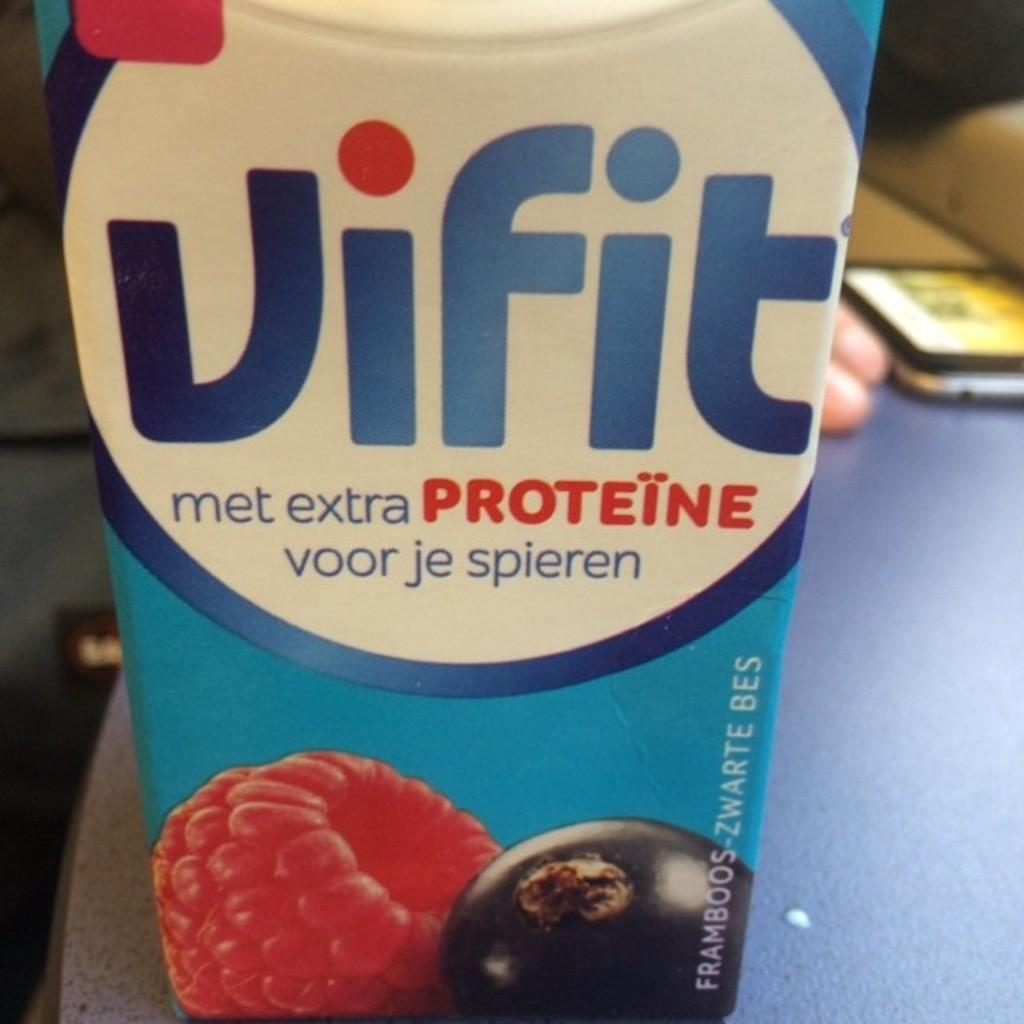<image>
Render a clear and concise summary of the photo. A carton of Vifit juice with extra proteine. 